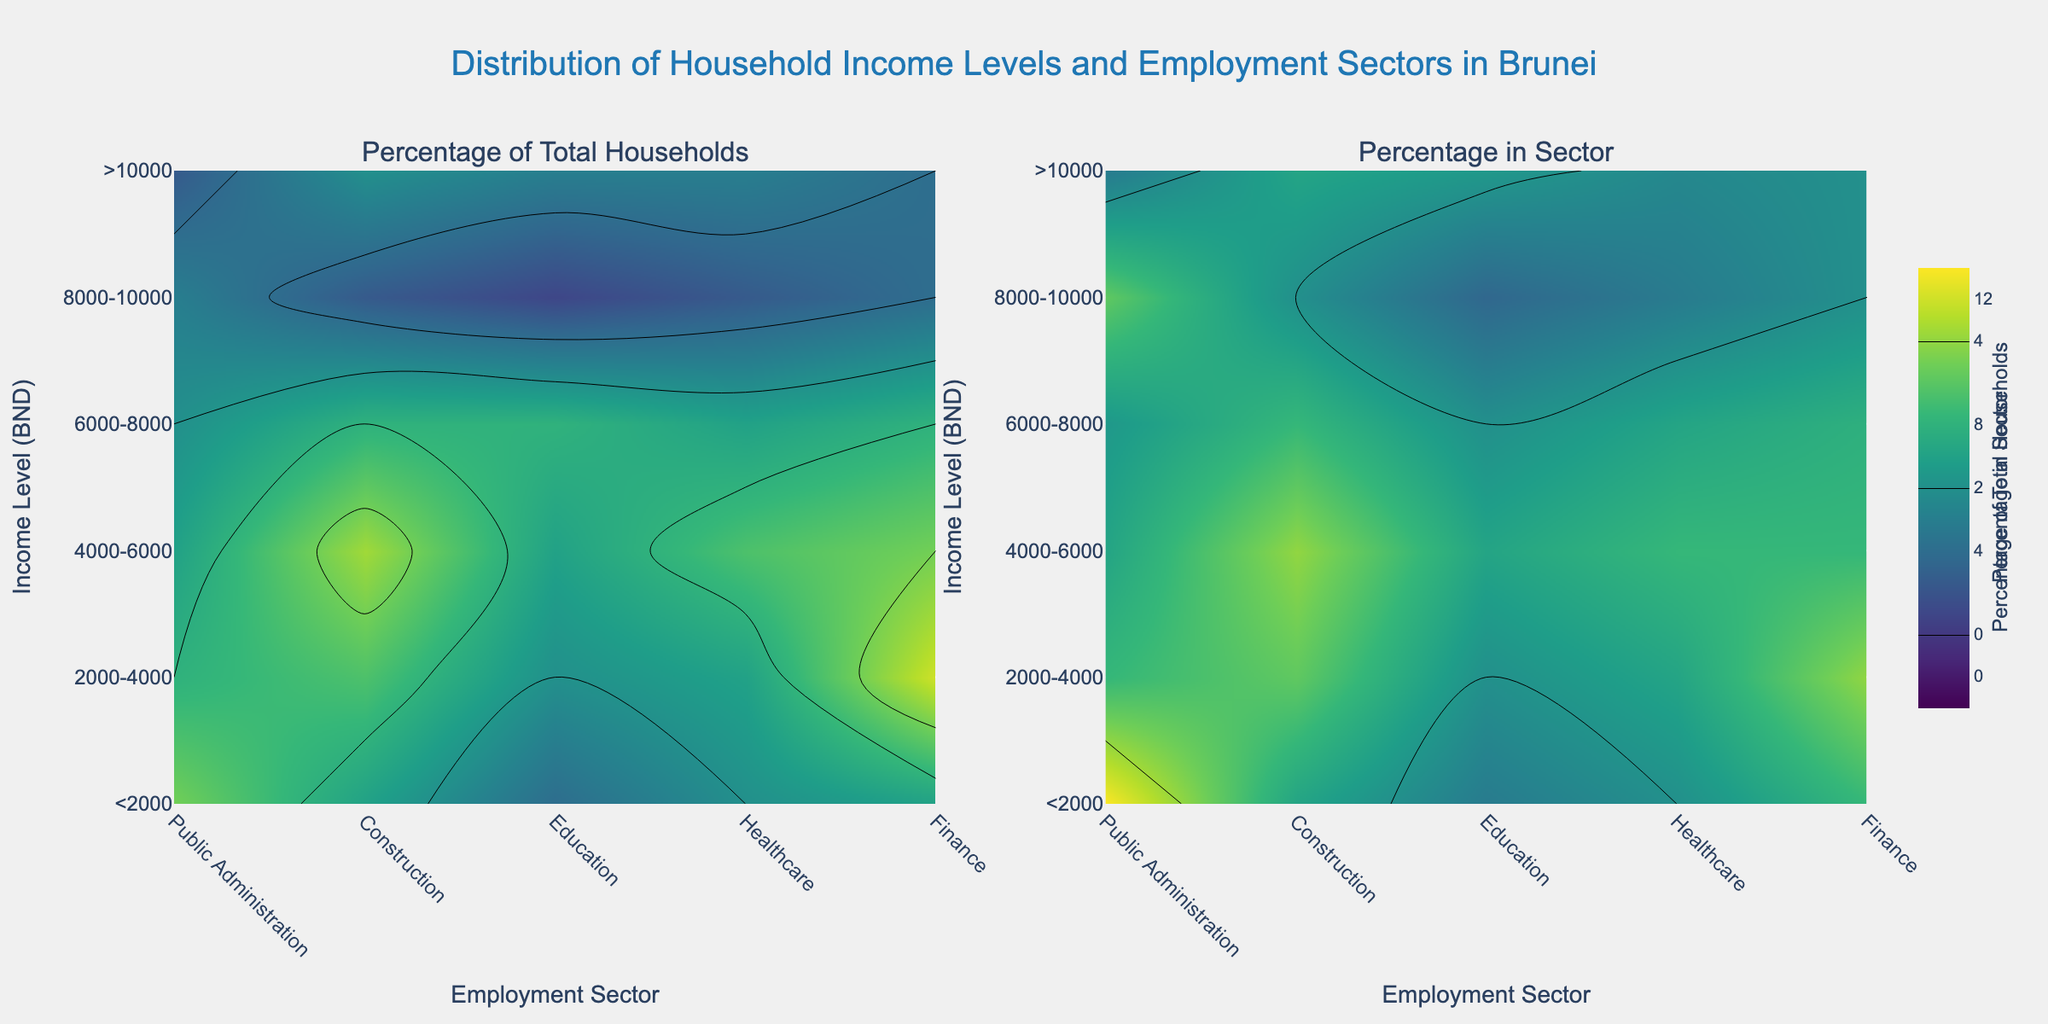What is the title of the plot? The title of the plot is displayed at the top and reads "Distribution of Household Income Levels and Employment Sectors in Brunei".
Answer: "Distribution of Household Income Levels and Employment Sectors in Brunei" What do the color bars on the right of each subplot represent? Each color bar indicates the range of percentages corresponding to the data in its respective subplot. The left subplot's color bar represents the "Percentage of Total Households", while the right subplot's color bar represents the "Percentage in Sector".
Answer: They represent the "Percentage of Total Households" and "Percentage in Sector" Which income level range has the highest percentage in the Education sector? In the right subplot, look for the highest contour values within the Education sector column. The darkest colors indicate the highest values. The 6000-8000 income level range has the highest percentage in the Education sector.
Answer: 6000-8000 Which employment sector has the highest percentage of total households in the 4000-6000 income level range? In the left subplot, locate the 4000-6000 income level row and identify the sector with the darkest color. Public Administration has the highest percentage of total households in this range.
Answer: Public Administration Compare the percentages for Public Administration and Finance sectors in the 2000-4000 income level range. Which is higher? In the left subplot, find the row for the 2000-4000 income level and compare the corresponding values in the Public Administration and Finance columns. Public Administration has the higher percentage.
Answer: Public Administration Are there any income levels where the Healthcare sector has a higher percentage of total households than the Construction sector? Visually compare the colors in the Healthcare and Construction columns across all income levels in the left subplot. There are no income levels where Healthcare surpasses Construction.
Answer: No What is the percentage of households in the >10000 income level working in the Public Administration sector? In the right subplot, locate the >10000 income level row and find the corresponding value in the Public Administration column. The value is approximately 2%.
Answer: 2% How does the percentage of households in the Finance sector change as income levels increase? Observe the gradient change in the Finance sector column across increasing income levels in the left subplot. The percentage first increases and then decreases at higher income levels.
Answer: It first increases, then decreases Which employment sector has the smallest variation in percentage across all income levels? The smallest variation is determined by the least range of color change in a sector's column. Education shows relatively smaller variation in color intensity.
Answer: Education 